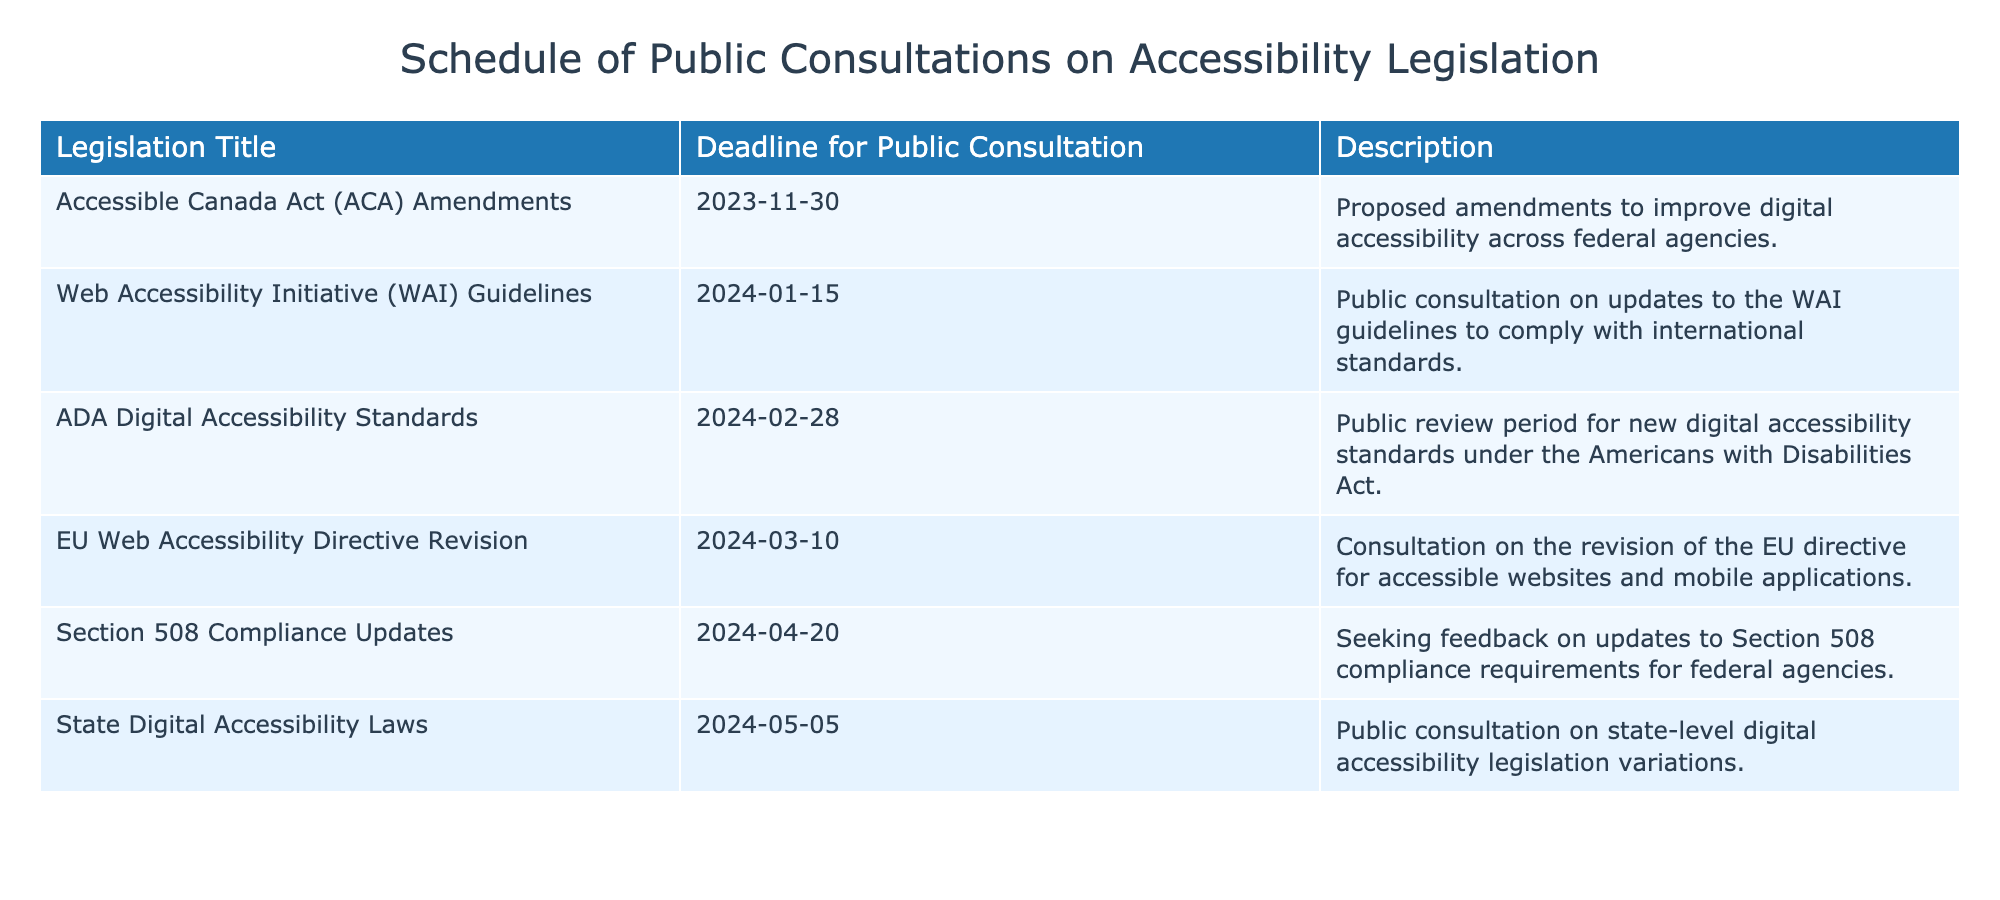What is the deadline for public consultation on the Accessible Canada Act amendments? The deadline listed in the table for the Accessible Canada Act amendments is 2023-11-30.
Answer: 2023-11-30 Which proposed legislation has the latest deadline for public consultation? According to the table, the legislation with the latest deadline for public consultation is the State Digital Accessibility Laws, which has a deadline of 2024-05-05.
Answer: State Digital Accessibility Laws Is there a public consultation scheduled before December 2023? Yes, the Accessible Canada Act Amendments have a public consultation deadline on 2023-11-30, which is before December 2023.
Answer: Yes What is the difference in days between the deadlines for the Web Accessibility Initiative Guidelines and the ADA Digital Accessibility Standards? The deadline for the Web Accessibility Initiative Guidelines is 2024-01-15, and for the ADA Digital Accessibility Standards, it is 2024-02-28. Calculating the difference involves counting the days: from January 15 to January 31 is 16 days, and from February 1 to February 28 is 28 days, leading to a total of 44 days difference.
Answer: 44 days How many proposed accessibility legislations have a deadline in the first quarter of 2024 (January to March)? The table shows that there are three pieces of proposed legislation with deadlines in the first quarter of 2024: the Web Accessibility Initiative Guidelines (2024-01-15), the ADA Digital Accessibility Standards (2024-02-28), and the EU Web Accessibility Directive Revision (2024-03-10).
Answer: 3 